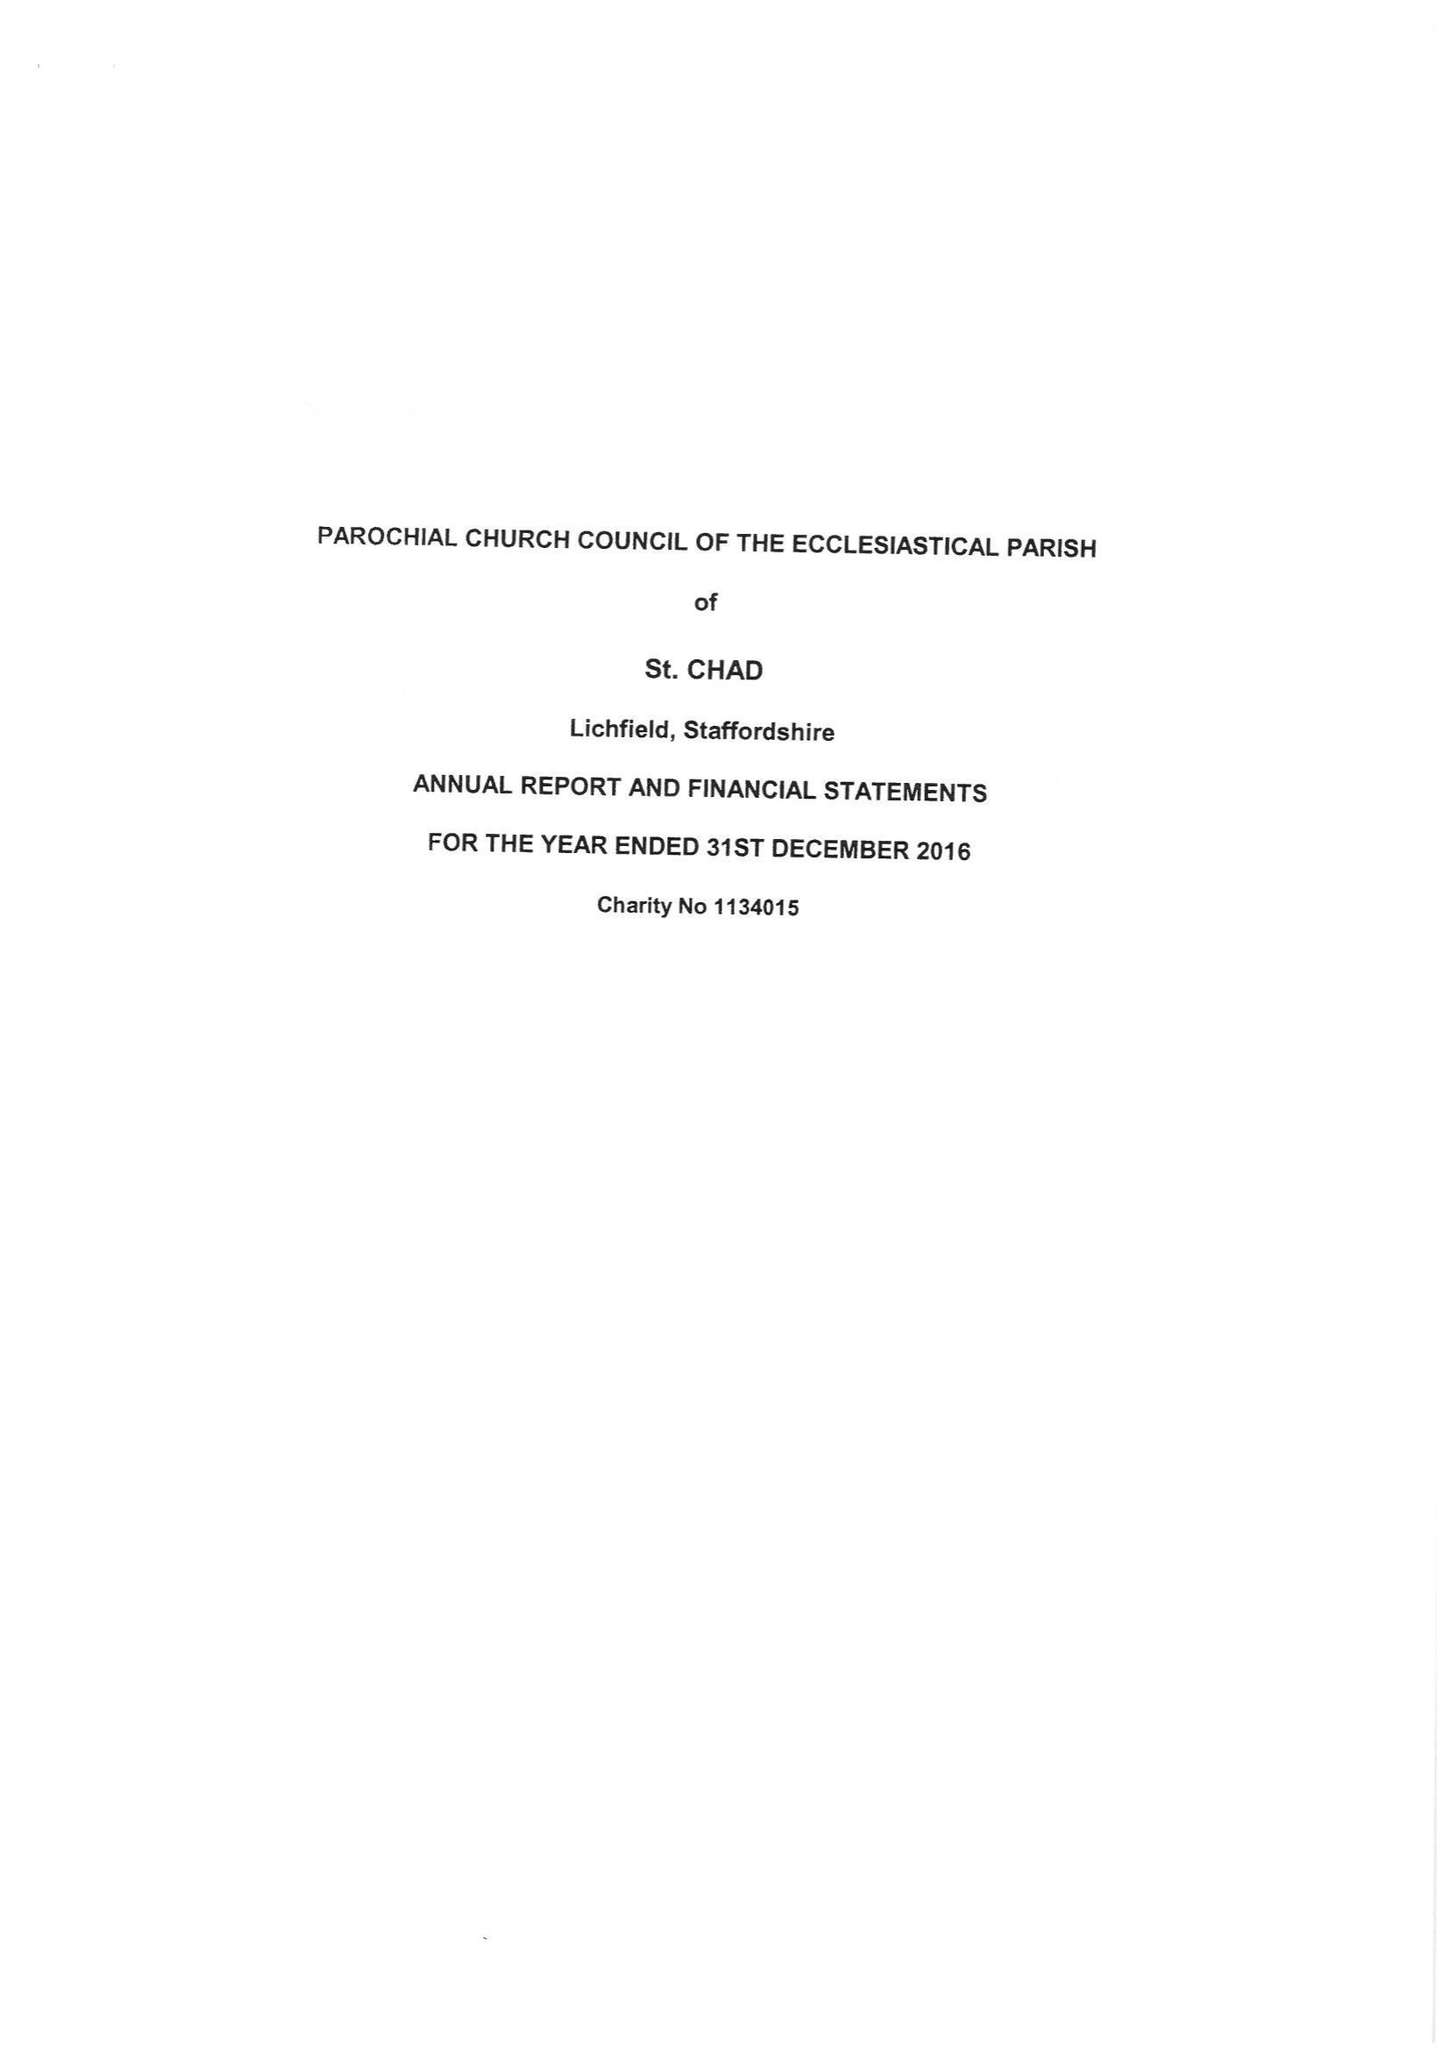What is the value for the address__post_town?
Answer the question using a single word or phrase. LICHFIELD 